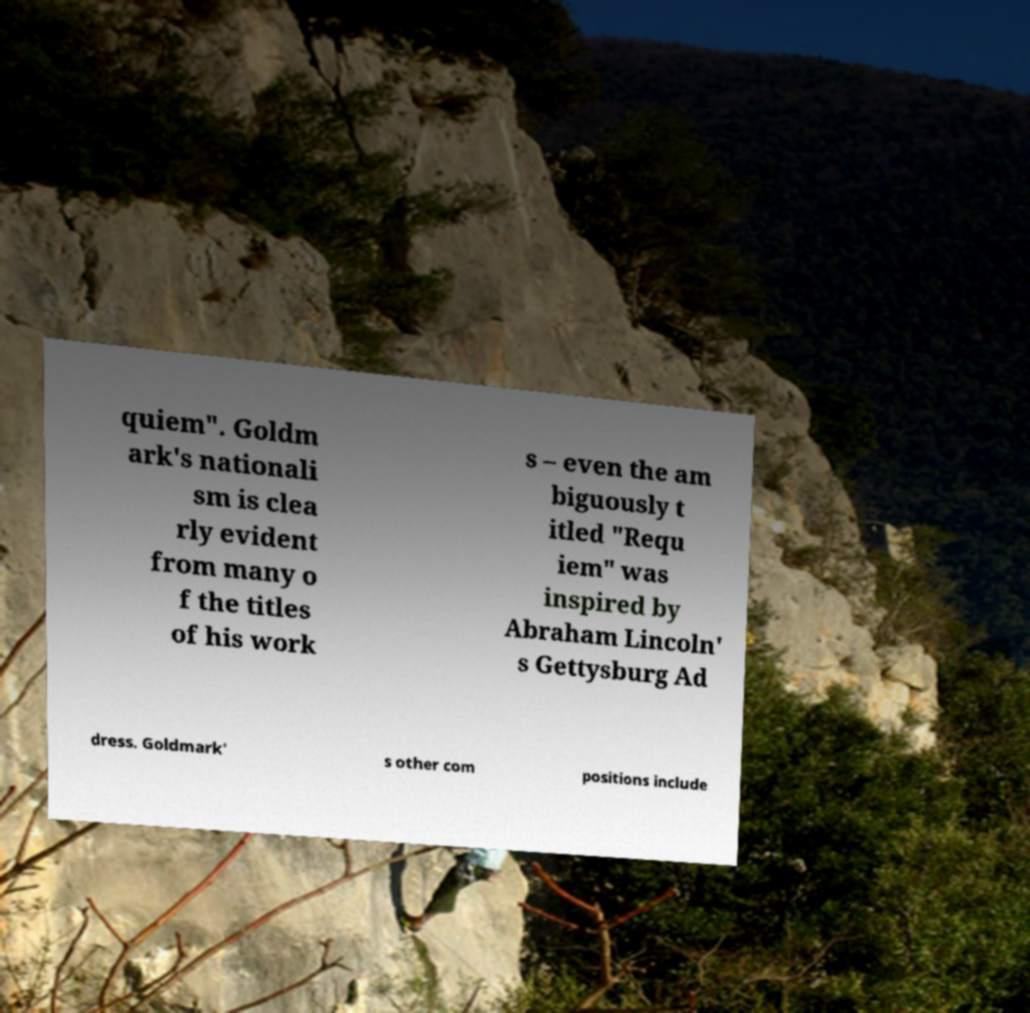There's text embedded in this image that I need extracted. Can you transcribe it verbatim? quiem". Goldm ark's nationali sm is clea rly evident from many o f the titles of his work s – even the am biguously t itled "Requ iem" was inspired by Abraham Lincoln' s Gettysburg Ad dress. Goldmark' s other com positions include 